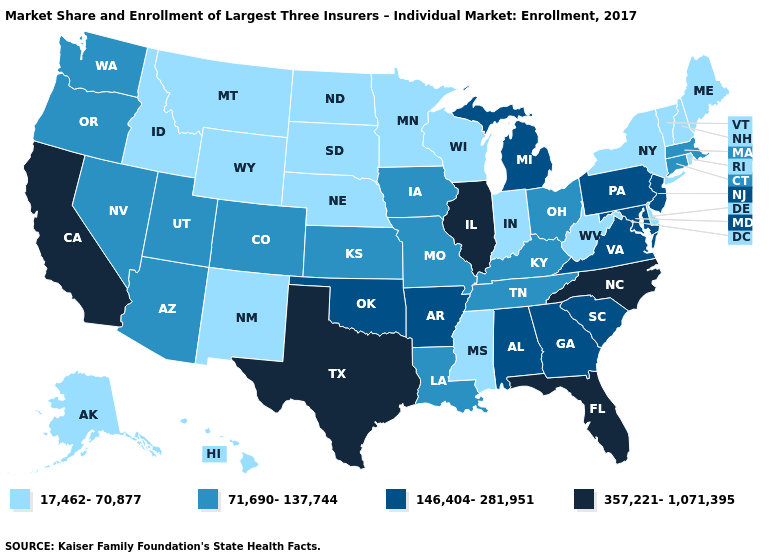Is the legend a continuous bar?
Quick response, please. No. Name the states that have a value in the range 146,404-281,951?
Quick response, please. Alabama, Arkansas, Georgia, Maryland, Michigan, New Jersey, Oklahoma, Pennsylvania, South Carolina, Virginia. Name the states that have a value in the range 146,404-281,951?
Write a very short answer. Alabama, Arkansas, Georgia, Maryland, Michigan, New Jersey, Oklahoma, Pennsylvania, South Carolina, Virginia. What is the lowest value in the USA?
Quick response, please. 17,462-70,877. What is the lowest value in the West?
Keep it brief. 17,462-70,877. Does the first symbol in the legend represent the smallest category?
Be succinct. Yes. What is the lowest value in states that border West Virginia?
Short answer required. 71,690-137,744. What is the value of Missouri?
Give a very brief answer. 71,690-137,744. What is the highest value in states that border Iowa?
Answer briefly. 357,221-1,071,395. What is the highest value in the Northeast ?
Concise answer only. 146,404-281,951. Does North Dakota have the lowest value in the MidWest?
Short answer required. Yes. What is the lowest value in the USA?
Short answer required. 17,462-70,877. Name the states that have a value in the range 146,404-281,951?
Concise answer only. Alabama, Arkansas, Georgia, Maryland, Michigan, New Jersey, Oklahoma, Pennsylvania, South Carolina, Virginia. Is the legend a continuous bar?
Quick response, please. No. What is the highest value in states that border Maine?
Be succinct. 17,462-70,877. 